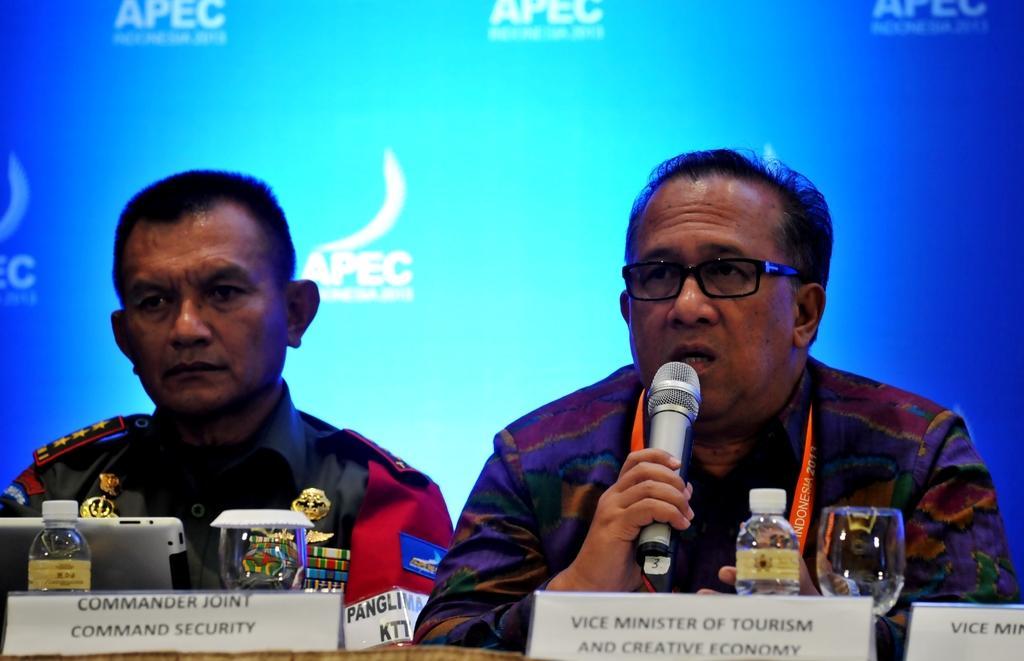In one or two sentences, can you explain what this image depicts? This 2 persons are sitting on a chair. This person is holding a mic and wore spectacles. On this table there is a bottle, glass and laptop. 